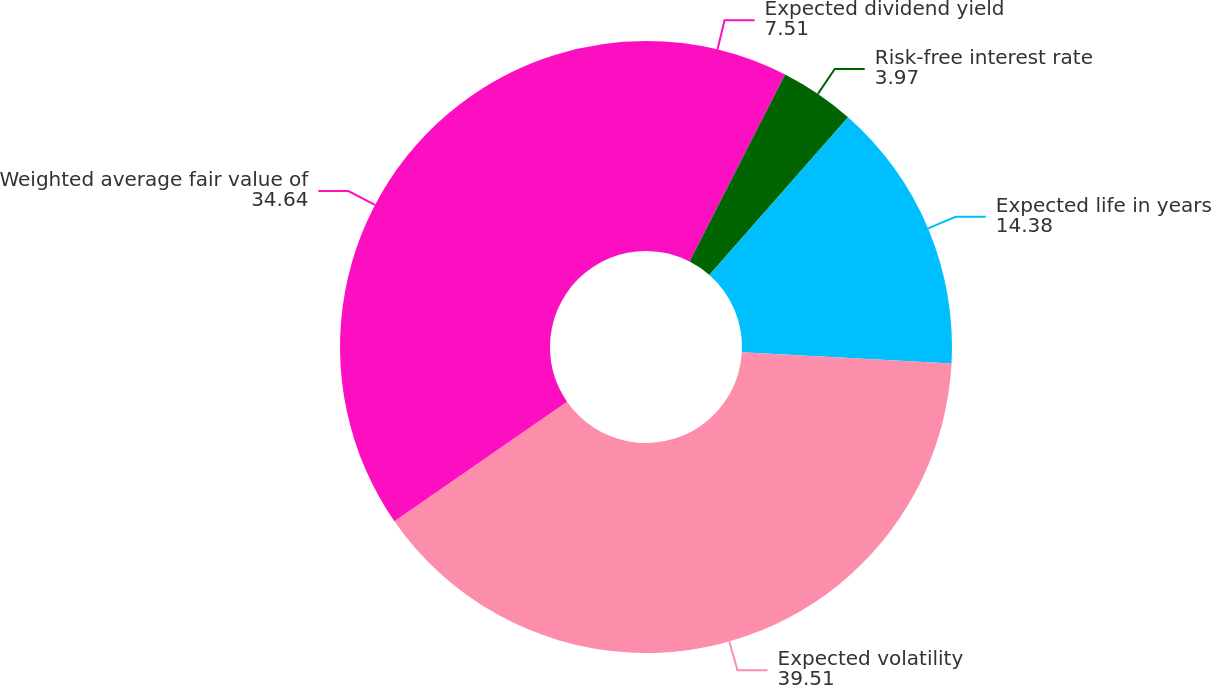<chart> <loc_0><loc_0><loc_500><loc_500><pie_chart><fcel>Expected dividend yield<fcel>Risk-free interest rate<fcel>Expected life in years<fcel>Expected volatility<fcel>Weighted average fair value of<nl><fcel>7.51%<fcel>3.97%<fcel>14.38%<fcel>39.51%<fcel>34.64%<nl></chart> 